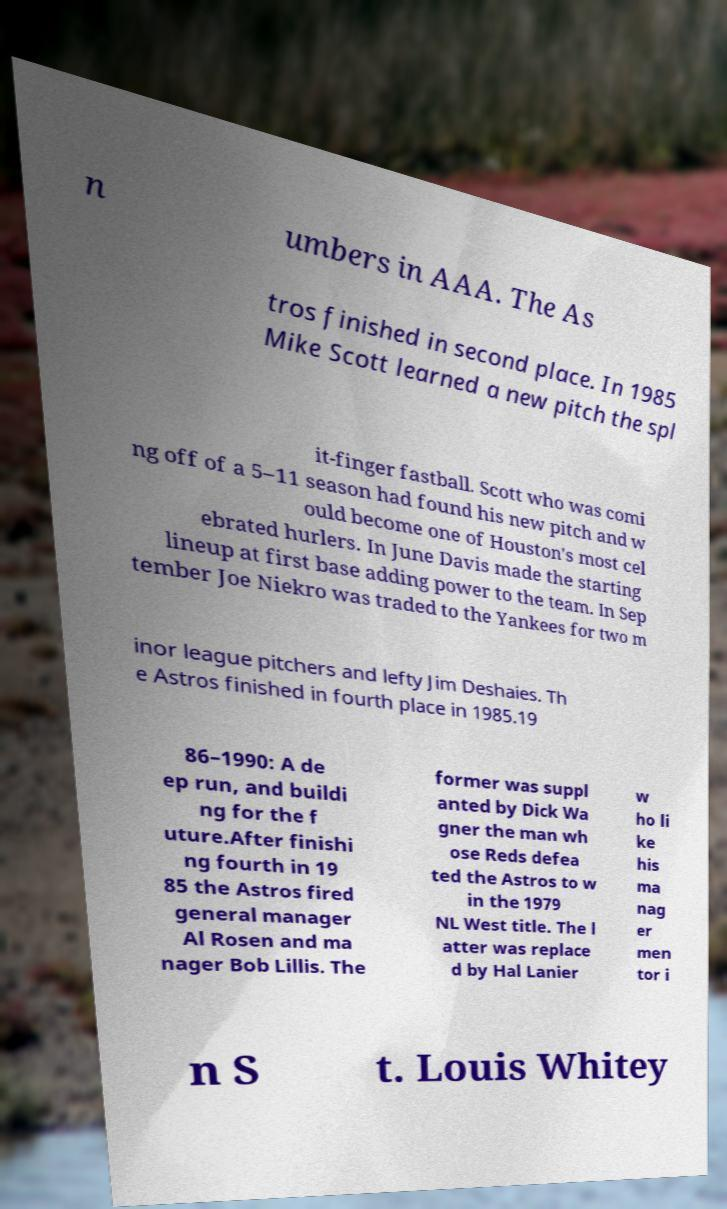There's text embedded in this image that I need extracted. Can you transcribe it verbatim? n umbers in AAA. The As tros finished in second place. In 1985 Mike Scott learned a new pitch the spl it-finger fastball. Scott who was comi ng off of a 5–11 season had found his new pitch and w ould become one of Houston's most cel ebrated hurlers. In June Davis made the starting lineup at first base adding power to the team. In Sep tember Joe Niekro was traded to the Yankees for two m inor league pitchers and lefty Jim Deshaies. Th e Astros finished in fourth place in 1985.19 86–1990: A de ep run, and buildi ng for the f uture.After finishi ng fourth in 19 85 the Astros fired general manager Al Rosen and ma nager Bob Lillis. The former was suppl anted by Dick Wa gner the man wh ose Reds defea ted the Astros to w in the 1979 NL West title. The l atter was replace d by Hal Lanier w ho li ke his ma nag er men tor i n S t. Louis Whitey 